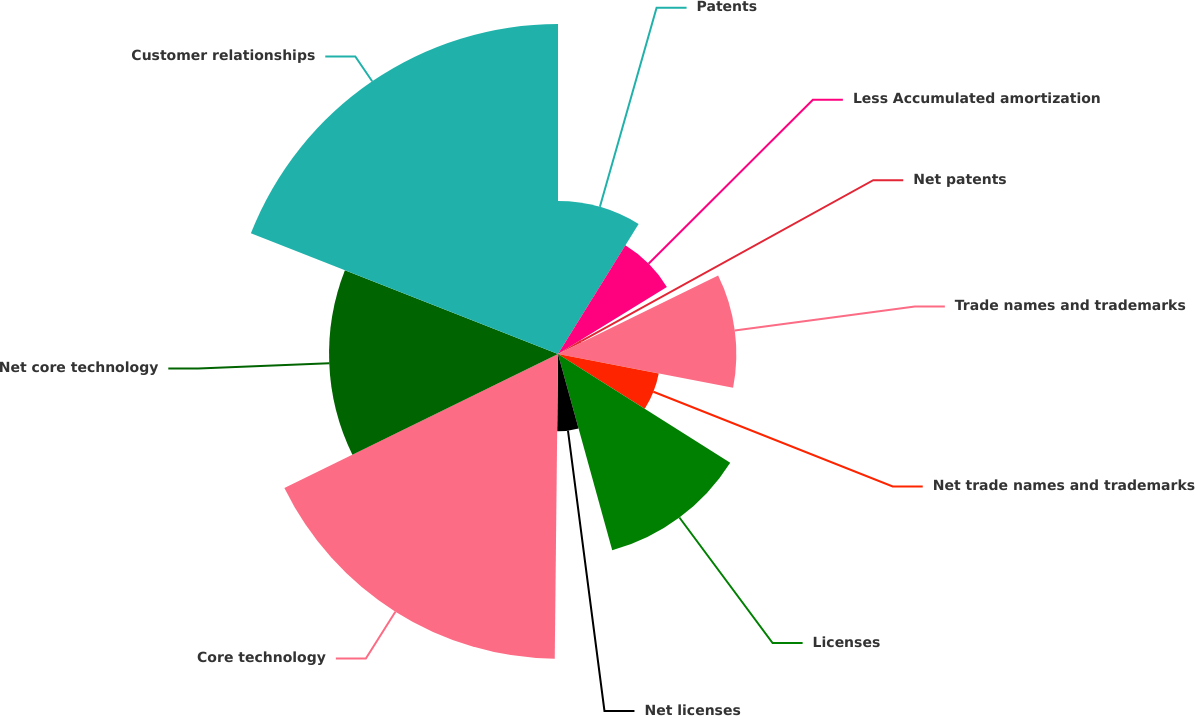Convert chart to OTSL. <chart><loc_0><loc_0><loc_500><loc_500><pie_chart><fcel>Patents<fcel>Less Accumulated amortization<fcel>Net patents<fcel>Trade names and trademarks<fcel>Net trade names and trademarks<fcel>Licenses<fcel>Net licenses<fcel>Core technology<fcel>Net core technology<fcel>Customer relationships<nl><fcel>8.83%<fcel>7.38%<fcel>1.54%<fcel>10.29%<fcel>5.92%<fcel>11.75%<fcel>4.46%<fcel>17.58%<fcel>13.21%<fcel>19.04%<nl></chart> 